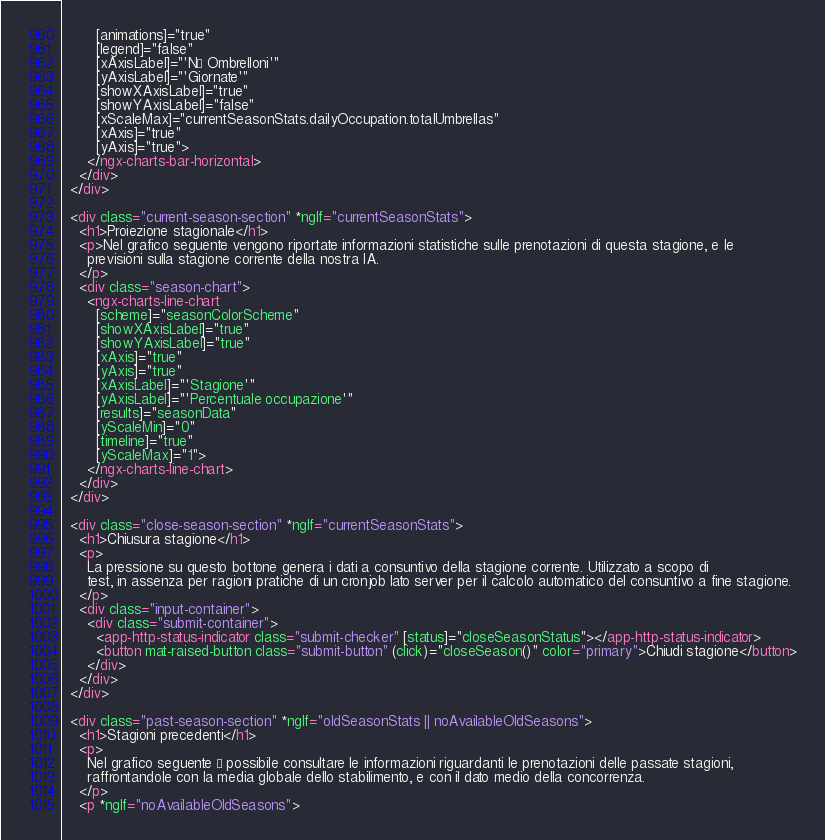<code> <loc_0><loc_0><loc_500><loc_500><_HTML_>        [animations]="true"
        [legend]="false"
        [xAxisLabel]="'N° Ombrelloni'"
        [yAxisLabel]="'Giornate'"
        [showXAxisLabel]="true"
        [showYAxisLabel]="false"
        [xScaleMax]="currentSeasonStats.dailyOccupation.totalUmbrellas"
        [xAxis]="true"
        [yAxis]="true">
      </ngx-charts-bar-horizontal>
    </div>
  </div>

  <div class="current-season-section" *ngIf="currentSeasonStats">
    <h1>Proiezione stagionale</h1>
    <p>Nel grafico seguente vengono riportate informazioni statistiche sulle prenotazioni di questa stagione, e le
      previsioni sulla stagione corrente della nostra IA.
    </p>
    <div class="season-chart">
      <ngx-charts-line-chart
        [scheme]="seasonColorScheme"
        [showXAxisLabel]="true"
        [showYAxisLabel]="true"
        [xAxis]="true"
        [yAxis]="true"
        [xAxisLabel]="'Stagione'"
        [yAxisLabel]="'Percentuale occupazione'"
        [results]="seasonData"
        [yScaleMin]="0"
        [timeline]="true"
        [yScaleMax]="1">
      </ngx-charts-line-chart>
    </div>
  </div>

  <div class="close-season-section" *ngIf="currentSeasonStats">
    <h1>Chiusura stagione</h1>
    <p>
      La pressione su questo bottone genera i dati a consuntivo della stagione corrente. Utilizzato a scopo di
      test, in assenza per ragioni pratiche di un cronjob lato server per il calcolo automatico del consuntivo a fine stagione.
    </p>
    <div class="input-container">
      <div class="submit-container">
        <app-http-status-indicator class="submit-checker" [status]="closeSeasonStatus"></app-http-status-indicator>
        <button mat-raised-button class="submit-button" (click)="closeSeason()" color="primary">Chiudi stagione</button>
      </div>
    </div>
  </div>

  <div class="past-season-section" *ngIf="oldSeasonStats || noAvailableOldSeasons">
    <h1>Stagioni precedenti</h1>
    <p>
      Nel grafico seguente è possibile consultare le informazioni riguardanti le prenotazioni delle passate stagioni,
      raffrontandole con la media globale dello stabilimento, e con il dato medio della concorrenza.
    </p>
    <p *ngIf="noAvailableOldSeasons"></code> 